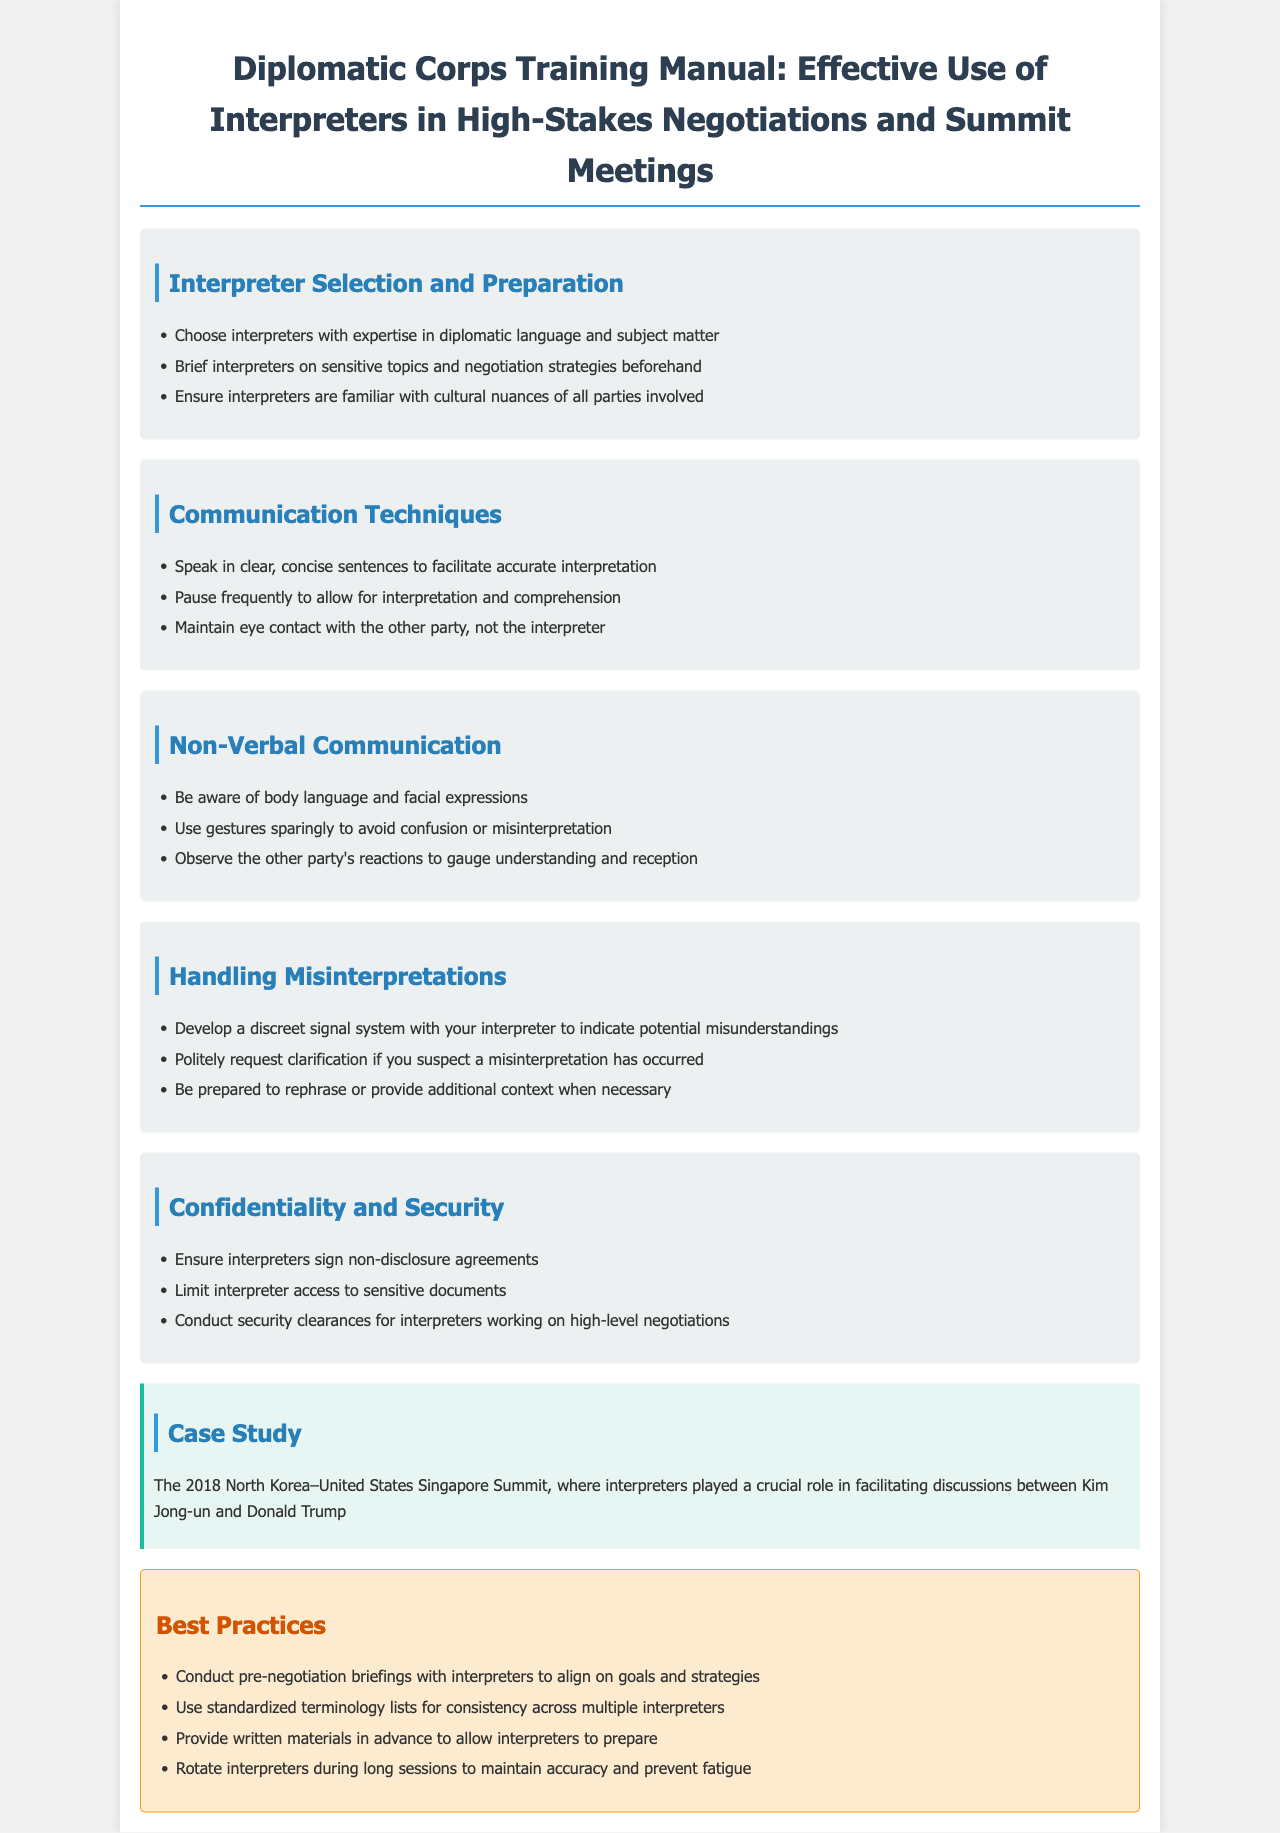What should interpreters be familiar with? Interpreters should be familiar with cultural nuances of all parties involved.
Answer: cultural nuances What is emphasized in communication techniques? The document emphasizes speaking in clear, concise sentences to facilitate accurate interpretation.
Answer: clear, concise sentences What should you develop with your interpreter for misunderstandings? You should develop a discreet signal system with your interpreter to indicate potential misunderstandings.
Answer: discreet signal system What is one best practice before negotiations? One best practice is to conduct pre-negotiation briefings with interpreters to align on goals and strategies.
Answer: conduct pre-negotiation briefings What significant event was highlighted as a case study? The document highlights the 2018 North Korea–United States Singapore Summit as a significant event.
Answer: 2018 North Korea–United States Singapore Summit How should interpreters be selected? Interpreters should be chosen with expertise in diplomatic language and subject matter.
Answer: expertise in diplomatic language and subject matter What should interpreters sign to ensure confidentiality? Interpreters should sign non-disclosure agreements to ensure confidentiality.
Answer: non-disclosure agreements What is a recommended action during long sessions? The recommended action is to rotate interpreters during long sessions to maintain accuracy.
Answer: rotate interpreters 